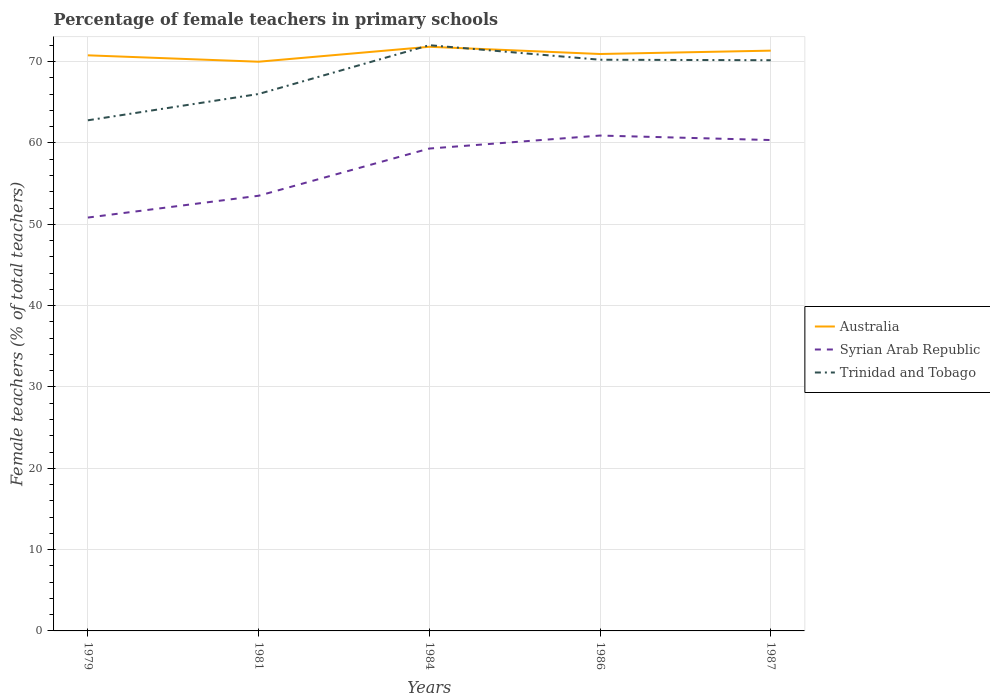Across all years, what is the maximum percentage of female teachers in Australia?
Make the answer very short. 69.99. What is the total percentage of female teachers in Trinidad and Tobago in the graph?
Offer a terse response. -7.39. What is the difference between the highest and the second highest percentage of female teachers in Syrian Arab Republic?
Make the answer very short. 10.08. What is the difference between the highest and the lowest percentage of female teachers in Trinidad and Tobago?
Provide a succinct answer. 3. How many years are there in the graph?
Provide a short and direct response. 5. What is the difference between two consecutive major ticks on the Y-axis?
Provide a succinct answer. 10. Are the values on the major ticks of Y-axis written in scientific E-notation?
Your response must be concise. No. How are the legend labels stacked?
Offer a very short reply. Vertical. What is the title of the graph?
Offer a very short reply. Percentage of female teachers in primary schools. What is the label or title of the Y-axis?
Keep it short and to the point. Female teachers (% of total teachers). What is the Female teachers (% of total teachers) of Australia in 1979?
Provide a short and direct response. 70.78. What is the Female teachers (% of total teachers) in Syrian Arab Republic in 1979?
Ensure brevity in your answer.  50.83. What is the Female teachers (% of total teachers) in Trinidad and Tobago in 1979?
Keep it short and to the point. 62.79. What is the Female teachers (% of total teachers) of Australia in 1981?
Provide a succinct answer. 69.99. What is the Female teachers (% of total teachers) in Syrian Arab Republic in 1981?
Ensure brevity in your answer.  53.51. What is the Female teachers (% of total teachers) of Trinidad and Tobago in 1981?
Keep it short and to the point. 66.02. What is the Female teachers (% of total teachers) in Australia in 1984?
Offer a terse response. 71.83. What is the Female teachers (% of total teachers) of Syrian Arab Republic in 1984?
Your response must be concise. 59.32. What is the Female teachers (% of total teachers) of Trinidad and Tobago in 1984?
Your response must be concise. 72.03. What is the Female teachers (% of total teachers) of Australia in 1986?
Keep it short and to the point. 70.94. What is the Female teachers (% of total teachers) in Syrian Arab Republic in 1986?
Offer a terse response. 60.91. What is the Female teachers (% of total teachers) of Trinidad and Tobago in 1986?
Provide a succinct answer. 70.24. What is the Female teachers (% of total teachers) in Australia in 1987?
Give a very brief answer. 71.36. What is the Female teachers (% of total teachers) of Syrian Arab Republic in 1987?
Make the answer very short. 60.36. What is the Female teachers (% of total teachers) in Trinidad and Tobago in 1987?
Ensure brevity in your answer.  70.18. Across all years, what is the maximum Female teachers (% of total teachers) of Australia?
Give a very brief answer. 71.83. Across all years, what is the maximum Female teachers (% of total teachers) in Syrian Arab Republic?
Ensure brevity in your answer.  60.91. Across all years, what is the maximum Female teachers (% of total teachers) in Trinidad and Tobago?
Give a very brief answer. 72.03. Across all years, what is the minimum Female teachers (% of total teachers) in Australia?
Your answer should be compact. 69.99. Across all years, what is the minimum Female teachers (% of total teachers) in Syrian Arab Republic?
Ensure brevity in your answer.  50.83. Across all years, what is the minimum Female teachers (% of total teachers) in Trinidad and Tobago?
Your response must be concise. 62.79. What is the total Female teachers (% of total teachers) of Australia in the graph?
Ensure brevity in your answer.  354.9. What is the total Female teachers (% of total teachers) in Syrian Arab Republic in the graph?
Provide a short and direct response. 284.94. What is the total Female teachers (% of total teachers) of Trinidad and Tobago in the graph?
Keep it short and to the point. 341.25. What is the difference between the Female teachers (% of total teachers) in Australia in 1979 and that in 1981?
Your answer should be compact. 0.79. What is the difference between the Female teachers (% of total teachers) of Syrian Arab Republic in 1979 and that in 1981?
Provide a succinct answer. -2.68. What is the difference between the Female teachers (% of total teachers) in Trinidad and Tobago in 1979 and that in 1981?
Offer a very short reply. -3.23. What is the difference between the Female teachers (% of total teachers) of Australia in 1979 and that in 1984?
Keep it short and to the point. -1.05. What is the difference between the Female teachers (% of total teachers) in Syrian Arab Republic in 1979 and that in 1984?
Offer a very short reply. -8.49. What is the difference between the Female teachers (% of total teachers) in Trinidad and Tobago in 1979 and that in 1984?
Give a very brief answer. -9.24. What is the difference between the Female teachers (% of total teachers) in Australia in 1979 and that in 1986?
Provide a short and direct response. -0.16. What is the difference between the Female teachers (% of total teachers) of Syrian Arab Republic in 1979 and that in 1986?
Keep it short and to the point. -10.08. What is the difference between the Female teachers (% of total teachers) of Trinidad and Tobago in 1979 and that in 1986?
Provide a short and direct response. -7.45. What is the difference between the Female teachers (% of total teachers) of Australia in 1979 and that in 1987?
Make the answer very short. -0.58. What is the difference between the Female teachers (% of total teachers) in Syrian Arab Republic in 1979 and that in 1987?
Your response must be concise. -9.53. What is the difference between the Female teachers (% of total teachers) of Trinidad and Tobago in 1979 and that in 1987?
Offer a terse response. -7.39. What is the difference between the Female teachers (% of total teachers) in Australia in 1981 and that in 1984?
Your response must be concise. -1.84. What is the difference between the Female teachers (% of total teachers) in Syrian Arab Republic in 1981 and that in 1984?
Ensure brevity in your answer.  -5.81. What is the difference between the Female teachers (% of total teachers) of Trinidad and Tobago in 1981 and that in 1984?
Your answer should be very brief. -6. What is the difference between the Female teachers (% of total teachers) of Australia in 1981 and that in 1986?
Keep it short and to the point. -0.95. What is the difference between the Female teachers (% of total teachers) in Syrian Arab Republic in 1981 and that in 1986?
Give a very brief answer. -7.4. What is the difference between the Female teachers (% of total teachers) of Trinidad and Tobago in 1981 and that in 1986?
Your answer should be very brief. -4.21. What is the difference between the Female teachers (% of total teachers) in Australia in 1981 and that in 1987?
Keep it short and to the point. -1.36. What is the difference between the Female teachers (% of total teachers) of Syrian Arab Republic in 1981 and that in 1987?
Ensure brevity in your answer.  -6.85. What is the difference between the Female teachers (% of total teachers) in Trinidad and Tobago in 1981 and that in 1987?
Make the answer very short. -4.15. What is the difference between the Female teachers (% of total teachers) in Australia in 1984 and that in 1986?
Make the answer very short. 0.89. What is the difference between the Female teachers (% of total teachers) of Syrian Arab Republic in 1984 and that in 1986?
Give a very brief answer. -1.6. What is the difference between the Female teachers (% of total teachers) of Trinidad and Tobago in 1984 and that in 1986?
Give a very brief answer. 1.79. What is the difference between the Female teachers (% of total teachers) in Australia in 1984 and that in 1987?
Make the answer very short. 0.47. What is the difference between the Female teachers (% of total teachers) in Syrian Arab Republic in 1984 and that in 1987?
Your answer should be very brief. -1.05. What is the difference between the Female teachers (% of total teachers) of Trinidad and Tobago in 1984 and that in 1987?
Provide a succinct answer. 1.85. What is the difference between the Female teachers (% of total teachers) of Australia in 1986 and that in 1987?
Offer a very short reply. -0.41. What is the difference between the Female teachers (% of total teachers) of Syrian Arab Republic in 1986 and that in 1987?
Offer a terse response. 0.55. What is the difference between the Female teachers (% of total teachers) of Trinidad and Tobago in 1986 and that in 1987?
Ensure brevity in your answer.  0.06. What is the difference between the Female teachers (% of total teachers) in Australia in 1979 and the Female teachers (% of total teachers) in Syrian Arab Republic in 1981?
Give a very brief answer. 17.27. What is the difference between the Female teachers (% of total teachers) in Australia in 1979 and the Female teachers (% of total teachers) in Trinidad and Tobago in 1981?
Offer a terse response. 4.76. What is the difference between the Female teachers (% of total teachers) in Syrian Arab Republic in 1979 and the Female teachers (% of total teachers) in Trinidad and Tobago in 1981?
Provide a short and direct response. -15.19. What is the difference between the Female teachers (% of total teachers) in Australia in 1979 and the Female teachers (% of total teachers) in Syrian Arab Republic in 1984?
Ensure brevity in your answer.  11.46. What is the difference between the Female teachers (% of total teachers) of Australia in 1979 and the Female teachers (% of total teachers) of Trinidad and Tobago in 1984?
Keep it short and to the point. -1.25. What is the difference between the Female teachers (% of total teachers) of Syrian Arab Republic in 1979 and the Female teachers (% of total teachers) of Trinidad and Tobago in 1984?
Your answer should be very brief. -21.2. What is the difference between the Female teachers (% of total teachers) of Australia in 1979 and the Female teachers (% of total teachers) of Syrian Arab Republic in 1986?
Your answer should be compact. 9.87. What is the difference between the Female teachers (% of total teachers) of Australia in 1979 and the Female teachers (% of total teachers) of Trinidad and Tobago in 1986?
Make the answer very short. 0.54. What is the difference between the Female teachers (% of total teachers) of Syrian Arab Republic in 1979 and the Female teachers (% of total teachers) of Trinidad and Tobago in 1986?
Ensure brevity in your answer.  -19.41. What is the difference between the Female teachers (% of total teachers) of Australia in 1979 and the Female teachers (% of total teachers) of Syrian Arab Republic in 1987?
Provide a succinct answer. 10.42. What is the difference between the Female teachers (% of total teachers) of Australia in 1979 and the Female teachers (% of total teachers) of Trinidad and Tobago in 1987?
Your answer should be compact. 0.6. What is the difference between the Female teachers (% of total teachers) of Syrian Arab Republic in 1979 and the Female teachers (% of total teachers) of Trinidad and Tobago in 1987?
Ensure brevity in your answer.  -19.35. What is the difference between the Female teachers (% of total teachers) of Australia in 1981 and the Female teachers (% of total teachers) of Syrian Arab Republic in 1984?
Your answer should be very brief. 10.68. What is the difference between the Female teachers (% of total teachers) in Australia in 1981 and the Female teachers (% of total teachers) in Trinidad and Tobago in 1984?
Your answer should be compact. -2.03. What is the difference between the Female teachers (% of total teachers) of Syrian Arab Republic in 1981 and the Female teachers (% of total teachers) of Trinidad and Tobago in 1984?
Give a very brief answer. -18.52. What is the difference between the Female teachers (% of total teachers) in Australia in 1981 and the Female teachers (% of total teachers) in Syrian Arab Republic in 1986?
Your answer should be compact. 9.08. What is the difference between the Female teachers (% of total teachers) in Australia in 1981 and the Female teachers (% of total teachers) in Trinidad and Tobago in 1986?
Your response must be concise. -0.24. What is the difference between the Female teachers (% of total teachers) of Syrian Arab Republic in 1981 and the Female teachers (% of total teachers) of Trinidad and Tobago in 1986?
Make the answer very short. -16.73. What is the difference between the Female teachers (% of total teachers) of Australia in 1981 and the Female teachers (% of total teachers) of Syrian Arab Republic in 1987?
Keep it short and to the point. 9.63. What is the difference between the Female teachers (% of total teachers) of Australia in 1981 and the Female teachers (% of total teachers) of Trinidad and Tobago in 1987?
Your answer should be very brief. -0.18. What is the difference between the Female teachers (% of total teachers) in Syrian Arab Republic in 1981 and the Female teachers (% of total teachers) in Trinidad and Tobago in 1987?
Your answer should be compact. -16.66. What is the difference between the Female teachers (% of total teachers) of Australia in 1984 and the Female teachers (% of total teachers) of Syrian Arab Republic in 1986?
Keep it short and to the point. 10.92. What is the difference between the Female teachers (% of total teachers) of Australia in 1984 and the Female teachers (% of total teachers) of Trinidad and Tobago in 1986?
Give a very brief answer. 1.59. What is the difference between the Female teachers (% of total teachers) of Syrian Arab Republic in 1984 and the Female teachers (% of total teachers) of Trinidad and Tobago in 1986?
Your answer should be very brief. -10.92. What is the difference between the Female teachers (% of total teachers) in Australia in 1984 and the Female teachers (% of total teachers) in Syrian Arab Republic in 1987?
Your answer should be very brief. 11.47. What is the difference between the Female teachers (% of total teachers) in Australia in 1984 and the Female teachers (% of total teachers) in Trinidad and Tobago in 1987?
Ensure brevity in your answer.  1.66. What is the difference between the Female teachers (% of total teachers) of Syrian Arab Republic in 1984 and the Female teachers (% of total teachers) of Trinidad and Tobago in 1987?
Provide a short and direct response. -10.86. What is the difference between the Female teachers (% of total teachers) in Australia in 1986 and the Female teachers (% of total teachers) in Syrian Arab Republic in 1987?
Offer a very short reply. 10.58. What is the difference between the Female teachers (% of total teachers) in Australia in 1986 and the Female teachers (% of total teachers) in Trinidad and Tobago in 1987?
Your answer should be compact. 0.77. What is the difference between the Female teachers (% of total teachers) of Syrian Arab Republic in 1986 and the Female teachers (% of total teachers) of Trinidad and Tobago in 1987?
Provide a succinct answer. -9.26. What is the average Female teachers (% of total teachers) of Australia per year?
Provide a succinct answer. 70.98. What is the average Female teachers (% of total teachers) of Syrian Arab Republic per year?
Ensure brevity in your answer.  56.99. What is the average Female teachers (% of total teachers) of Trinidad and Tobago per year?
Make the answer very short. 68.25. In the year 1979, what is the difference between the Female teachers (% of total teachers) of Australia and Female teachers (% of total teachers) of Syrian Arab Republic?
Your answer should be very brief. 19.95. In the year 1979, what is the difference between the Female teachers (% of total teachers) of Australia and Female teachers (% of total teachers) of Trinidad and Tobago?
Keep it short and to the point. 7.99. In the year 1979, what is the difference between the Female teachers (% of total teachers) in Syrian Arab Republic and Female teachers (% of total teachers) in Trinidad and Tobago?
Keep it short and to the point. -11.96. In the year 1981, what is the difference between the Female teachers (% of total teachers) of Australia and Female teachers (% of total teachers) of Syrian Arab Republic?
Keep it short and to the point. 16.48. In the year 1981, what is the difference between the Female teachers (% of total teachers) in Australia and Female teachers (% of total teachers) in Trinidad and Tobago?
Provide a succinct answer. 3.97. In the year 1981, what is the difference between the Female teachers (% of total teachers) in Syrian Arab Republic and Female teachers (% of total teachers) in Trinidad and Tobago?
Provide a succinct answer. -12.51. In the year 1984, what is the difference between the Female teachers (% of total teachers) of Australia and Female teachers (% of total teachers) of Syrian Arab Republic?
Give a very brief answer. 12.51. In the year 1984, what is the difference between the Female teachers (% of total teachers) in Australia and Female teachers (% of total teachers) in Trinidad and Tobago?
Your answer should be very brief. -0.19. In the year 1984, what is the difference between the Female teachers (% of total teachers) in Syrian Arab Republic and Female teachers (% of total teachers) in Trinidad and Tobago?
Your answer should be very brief. -12.71. In the year 1986, what is the difference between the Female teachers (% of total teachers) in Australia and Female teachers (% of total teachers) in Syrian Arab Republic?
Offer a terse response. 10.03. In the year 1986, what is the difference between the Female teachers (% of total teachers) of Australia and Female teachers (% of total teachers) of Trinidad and Tobago?
Your response must be concise. 0.7. In the year 1986, what is the difference between the Female teachers (% of total teachers) of Syrian Arab Republic and Female teachers (% of total teachers) of Trinidad and Tobago?
Offer a terse response. -9.32. In the year 1987, what is the difference between the Female teachers (% of total teachers) of Australia and Female teachers (% of total teachers) of Syrian Arab Republic?
Keep it short and to the point. 10.99. In the year 1987, what is the difference between the Female teachers (% of total teachers) in Australia and Female teachers (% of total teachers) in Trinidad and Tobago?
Provide a short and direct response. 1.18. In the year 1987, what is the difference between the Female teachers (% of total teachers) of Syrian Arab Republic and Female teachers (% of total teachers) of Trinidad and Tobago?
Your response must be concise. -9.81. What is the ratio of the Female teachers (% of total teachers) of Australia in 1979 to that in 1981?
Your answer should be very brief. 1.01. What is the ratio of the Female teachers (% of total teachers) in Syrian Arab Republic in 1979 to that in 1981?
Your answer should be very brief. 0.95. What is the ratio of the Female teachers (% of total teachers) of Trinidad and Tobago in 1979 to that in 1981?
Your answer should be compact. 0.95. What is the ratio of the Female teachers (% of total teachers) of Australia in 1979 to that in 1984?
Your answer should be compact. 0.99. What is the ratio of the Female teachers (% of total teachers) in Syrian Arab Republic in 1979 to that in 1984?
Ensure brevity in your answer.  0.86. What is the ratio of the Female teachers (% of total teachers) in Trinidad and Tobago in 1979 to that in 1984?
Offer a terse response. 0.87. What is the ratio of the Female teachers (% of total teachers) in Australia in 1979 to that in 1986?
Your answer should be compact. 1. What is the ratio of the Female teachers (% of total teachers) in Syrian Arab Republic in 1979 to that in 1986?
Your answer should be compact. 0.83. What is the ratio of the Female teachers (% of total teachers) of Trinidad and Tobago in 1979 to that in 1986?
Make the answer very short. 0.89. What is the ratio of the Female teachers (% of total teachers) in Syrian Arab Republic in 1979 to that in 1987?
Make the answer very short. 0.84. What is the ratio of the Female teachers (% of total teachers) of Trinidad and Tobago in 1979 to that in 1987?
Your response must be concise. 0.89. What is the ratio of the Female teachers (% of total teachers) of Australia in 1981 to that in 1984?
Your answer should be compact. 0.97. What is the ratio of the Female teachers (% of total teachers) in Syrian Arab Republic in 1981 to that in 1984?
Make the answer very short. 0.9. What is the ratio of the Female teachers (% of total teachers) in Trinidad and Tobago in 1981 to that in 1984?
Make the answer very short. 0.92. What is the ratio of the Female teachers (% of total teachers) of Australia in 1981 to that in 1986?
Provide a short and direct response. 0.99. What is the ratio of the Female teachers (% of total teachers) in Syrian Arab Republic in 1981 to that in 1986?
Give a very brief answer. 0.88. What is the ratio of the Female teachers (% of total teachers) of Australia in 1981 to that in 1987?
Your answer should be compact. 0.98. What is the ratio of the Female teachers (% of total teachers) of Syrian Arab Republic in 1981 to that in 1987?
Ensure brevity in your answer.  0.89. What is the ratio of the Female teachers (% of total teachers) in Trinidad and Tobago in 1981 to that in 1987?
Provide a short and direct response. 0.94. What is the ratio of the Female teachers (% of total teachers) of Australia in 1984 to that in 1986?
Offer a very short reply. 1.01. What is the ratio of the Female teachers (% of total teachers) in Syrian Arab Republic in 1984 to that in 1986?
Provide a short and direct response. 0.97. What is the ratio of the Female teachers (% of total teachers) in Trinidad and Tobago in 1984 to that in 1986?
Give a very brief answer. 1.03. What is the ratio of the Female teachers (% of total teachers) of Australia in 1984 to that in 1987?
Provide a succinct answer. 1.01. What is the ratio of the Female teachers (% of total teachers) in Syrian Arab Republic in 1984 to that in 1987?
Your answer should be very brief. 0.98. What is the ratio of the Female teachers (% of total teachers) of Trinidad and Tobago in 1984 to that in 1987?
Your answer should be very brief. 1.03. What is the ratio of the Female teachers (% of total teachers) of Australia in 1986 to that in 1987?
Offer a very short reply. 0.99. What is the ratio of the Female teachers (% of total teachers) of Syrian Arab Republic in 1986 to that in 1987?
Your answer should be very brief. 1.01. What is the difference between the highest and the second highest Female teachers (% of total teachers) of Australia?
Provide a short and direct response. 0.47. What is the difference between the highest and the second highest Female teachers (% of total teachers) of Syrian Arab Republic?
Offer a very short reply. 0.55. What is the difference between the highest and the second highest Female teachers (% of total teachers) in Trinidad and Tobago?
Provide a short and direct response. 1.79. What is the difference between the highest and the lowest Female teachers (% of total teachers) in Australia?
Your answer should be very brief. 1.84. What is the difference between the highest and the lowest Female teachers (% of total teachers) in Syrian Arab Republic?
Your answer should be very brief. 10.08. What is the difference between the highest and the lowest Female teachers (% of total teachers) in Trinidad and Tobago?
Ensure brevity in your answer.  9.24. 